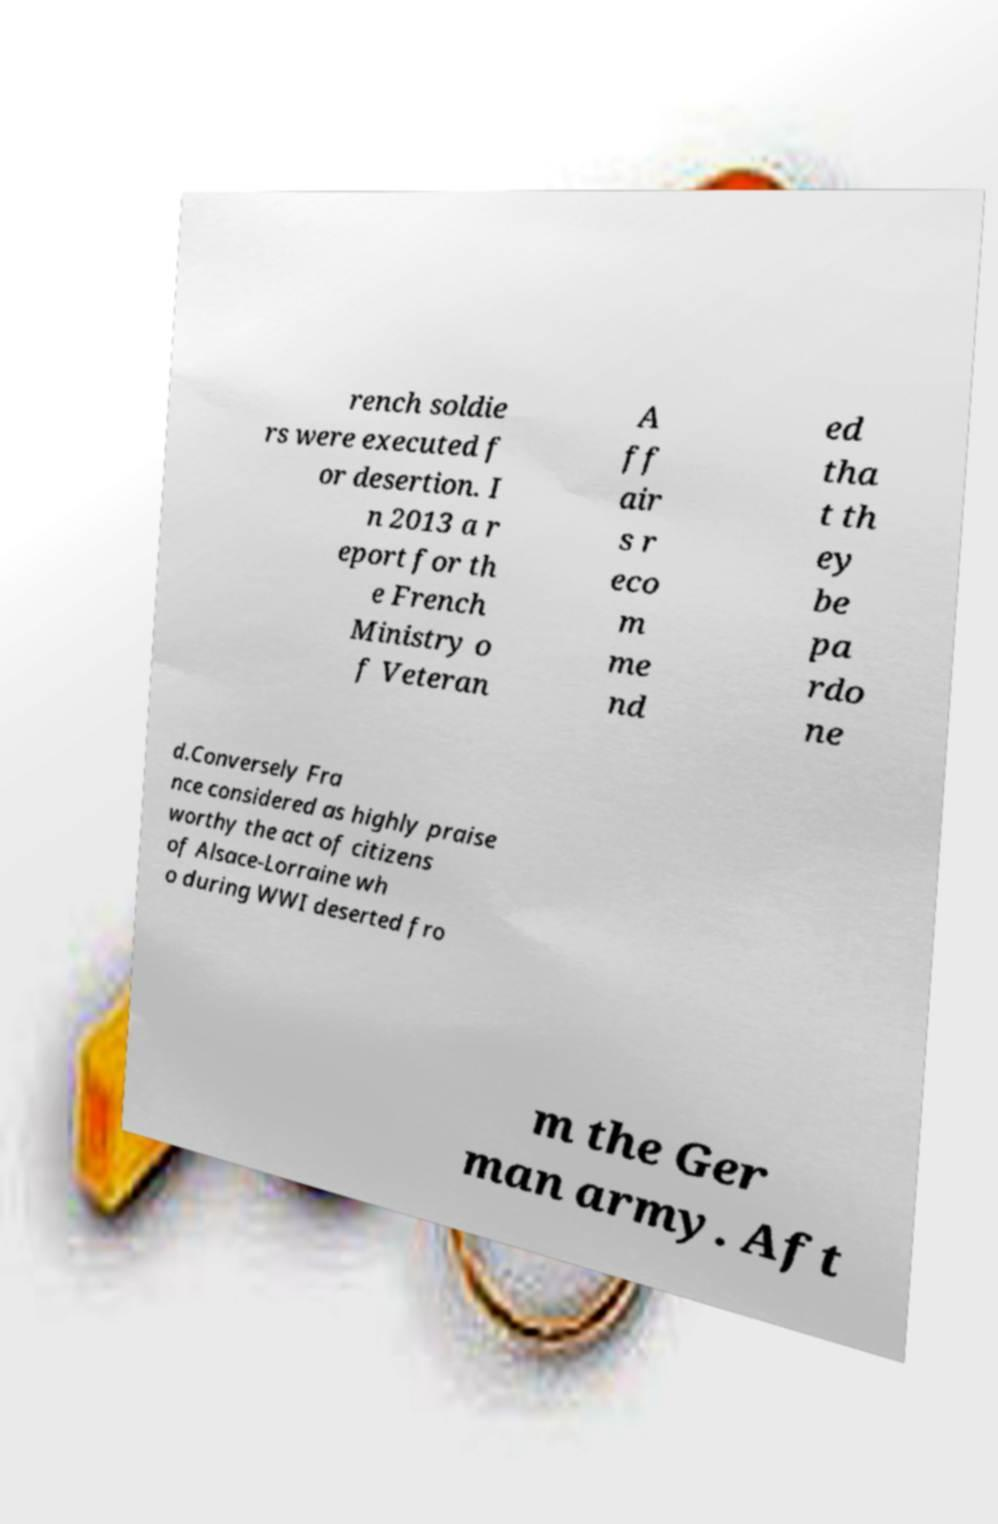Please identify and transcribe the text found in this image. rench soldie rs were executed f or desertion. I n 2013 a r eport for th e French Ministry o f Veteran A ff air s r eco m me nd ed tha t th ey be pa rdo ne d.Conversely Fra nce considered as highly praise worthy the act of citizens of Alsace-Lorraine wh o during WWI deserted fro m the Ger man army. Aft 